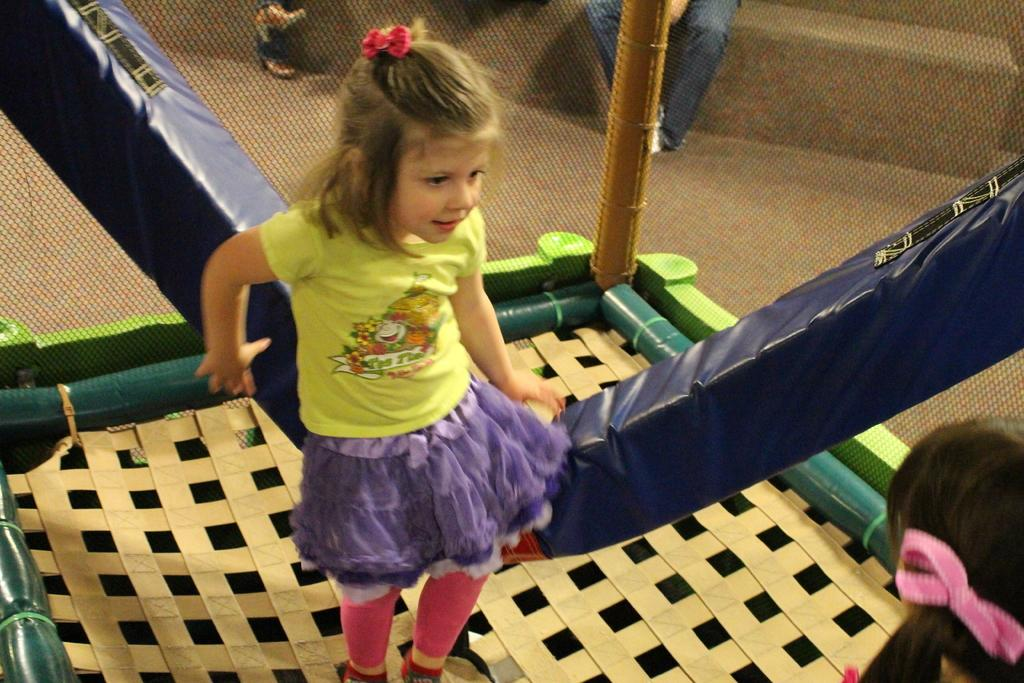What is the main subject of the image? There is a girl on a trampoline in the center of the image. Can you describe the people visible in the image? There are people visible at the top of the image. Where is the person's head located in the image? There is a person's head in the bottom right corner of the image. What type of silk fabric is draped over the tub in the image? There is no tub or silk fabric present in the image. 